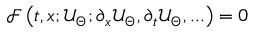Convert formula to latex. <formula><loc_0><loc_0><loc_500><loc_500>\mathcal { F } \left ( t , x ; \mathcal { U } _ { \Theta } ; \partial _ { x } \mathcal { U } _ { \Theta } , \partial _ { t } \mathcal { U } _ { \Theta } , \dots \right ) = 0</formula> 